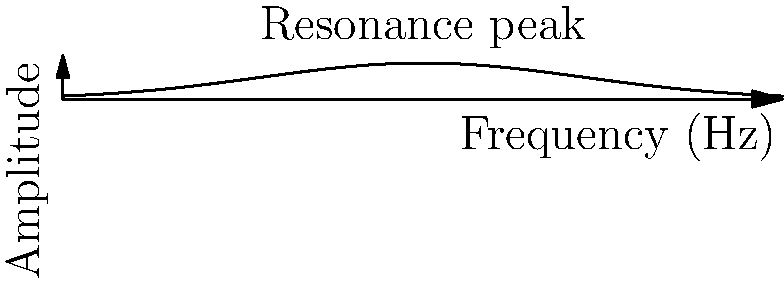A grove of pine trees in Burrillville experiences resonance when wind blows through it. The graph shows the amplitude of tree oscillation versus wind frequency. If the average height of the trees is 20 meters and the speed of sound in air is 343 m/s, what is the wavelength of the resonant frequency? To solve this problem, we'll follow these steps:

1. Identify the resonant frequency from the graph:
   The peak of the curve occurs at 5 Hz, so the resonant frequency is 5 Hz.

2. Recall the relationship between wavelength, frequency, and wave speed:
   $$v = f\lambda$$
   Where $v$ is the wave speed (speed of sound in this case), $f$ is the frequency, and $\lambda$ is the wavelength.

3. Rearrange the equation to solve for wavelength:
   $$\lambda = \frac{v}{f}$$

4. Substitute the known values:
   $v = 343$ m/s (speed of sound in air)
   $f = 5$ Hz (resonant frequency from the graph)

5. Calculate the wavelength:
   $$\lambda = \frac{343 \text{ m/s}}{5 \text{ Hz}} = 68.6 \text{ m}$$

6. Round to a reasonable number of significant figures:
   $\lambda \approx 69$ m

Note: The average height of the trees (20 m) is not directly used in this calculation but provides context for the scale of the phenomenon.
Answer: 69 m 